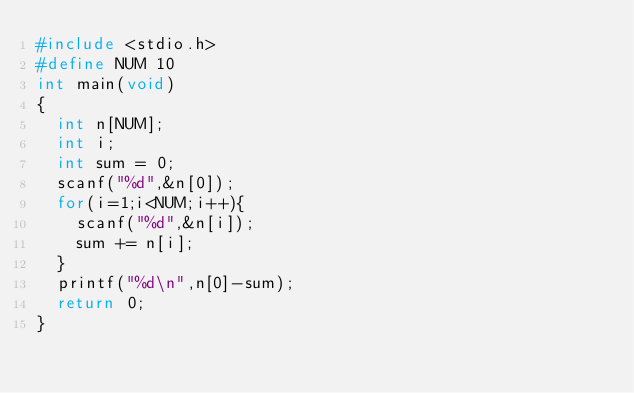<code> <loc_0><loc_0><loc_500><loc_500><_C_>#include <stdio.h>
#define NUM 10
int main(void)
{
  int n[NUM];
  int i;
  int sum = 0;
  scanf("%d",&n[0]);
  for(i=1;i<NUM;i++){
    scanf("%d",&n[i]);
    sum += n[i];
  }
  printf("%d\n",n[0]-sum);
  return 0;
}</code> 